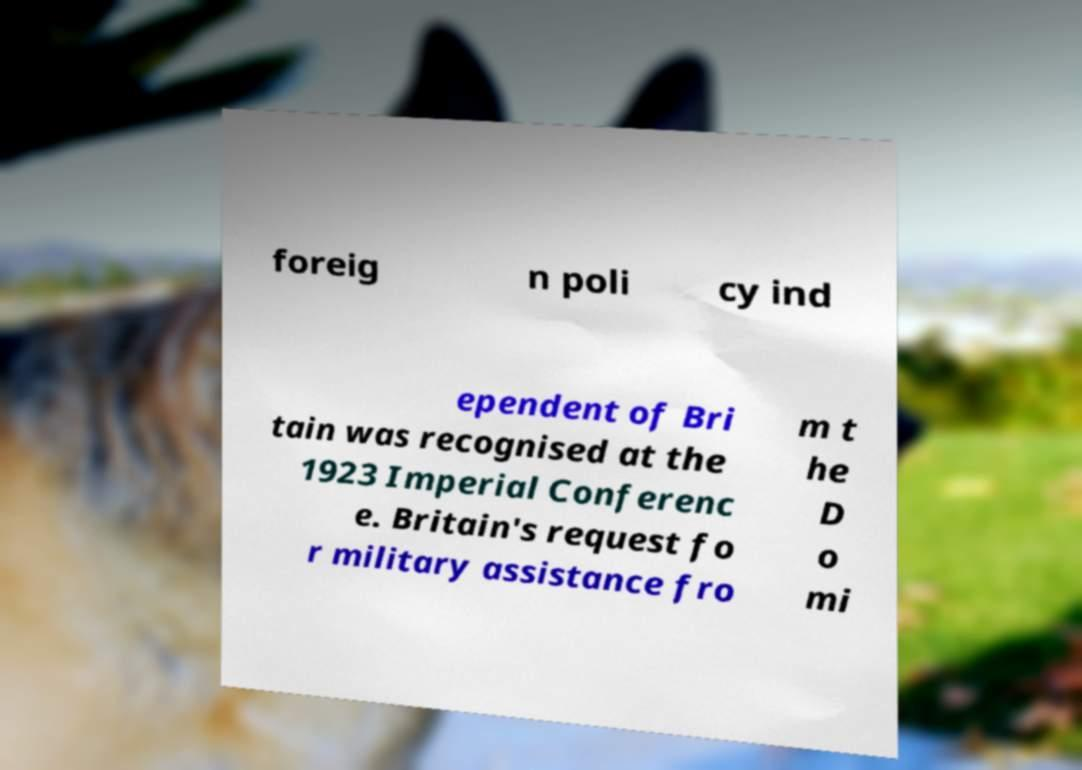Can you accurately transcribe the text from the provided image for me? foreig n poli cy ind ependent of Bri tain was recognised at the 1923 Imperial Conferenc e. Britain's request fo r military assistance fro m t he D o mi 